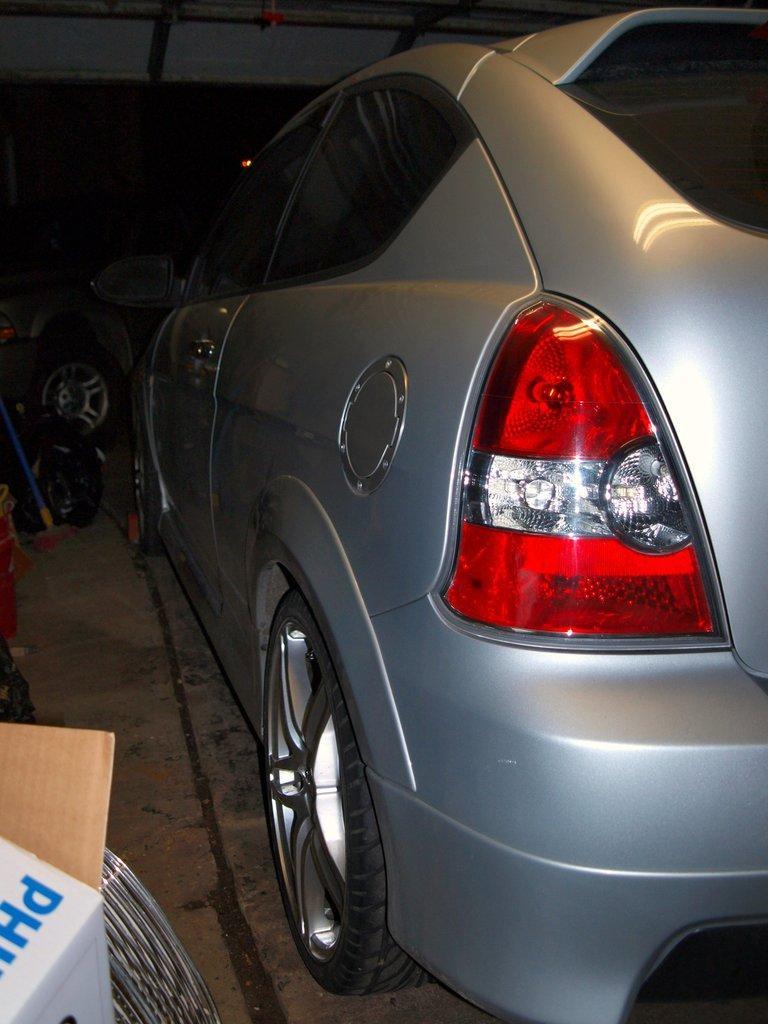Describe this image in one or two sentences. Here we can see a car on the surface and left side bottom of the image we can see box. Background we can see wheels. 